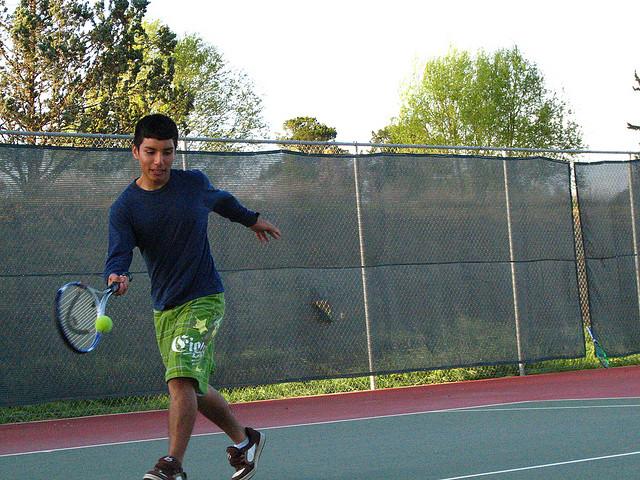How many hands is on the racket?
Concise answer only. 1. What is surrounding the tennis court?
Answer briefly. Fence. What color is the out-of-bounds area of the court?
Be succinct. Red. 